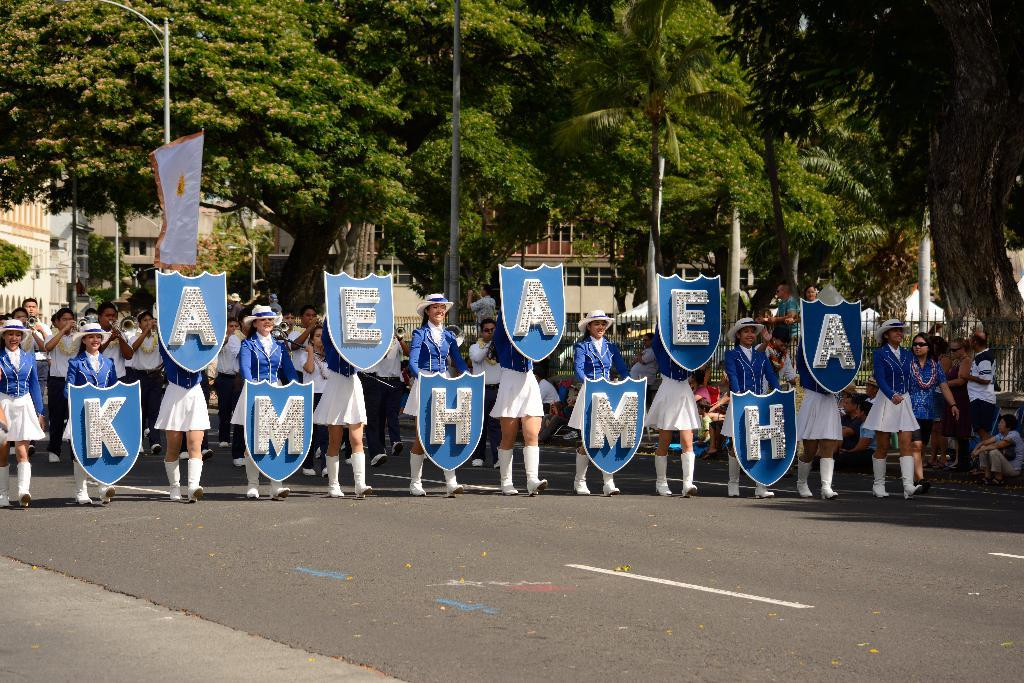Who are the people in the image? There are school girls in the image. What are the school girls holding in the image? The school girls are holding alphabet boards. What are the school girls doing in the image? The school girls are walking on the street. What can be seen in the background of the image? There are trees visible in the background of the image. What type of floor can be seen in the image? There is no floor visible in the image; it shows school girls walking on the street. 